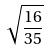<formula> <loc_0><loc_0><loc_500><loc_500>\sqrt { \frac { 1 6 } { 3 5 } }</formula> 